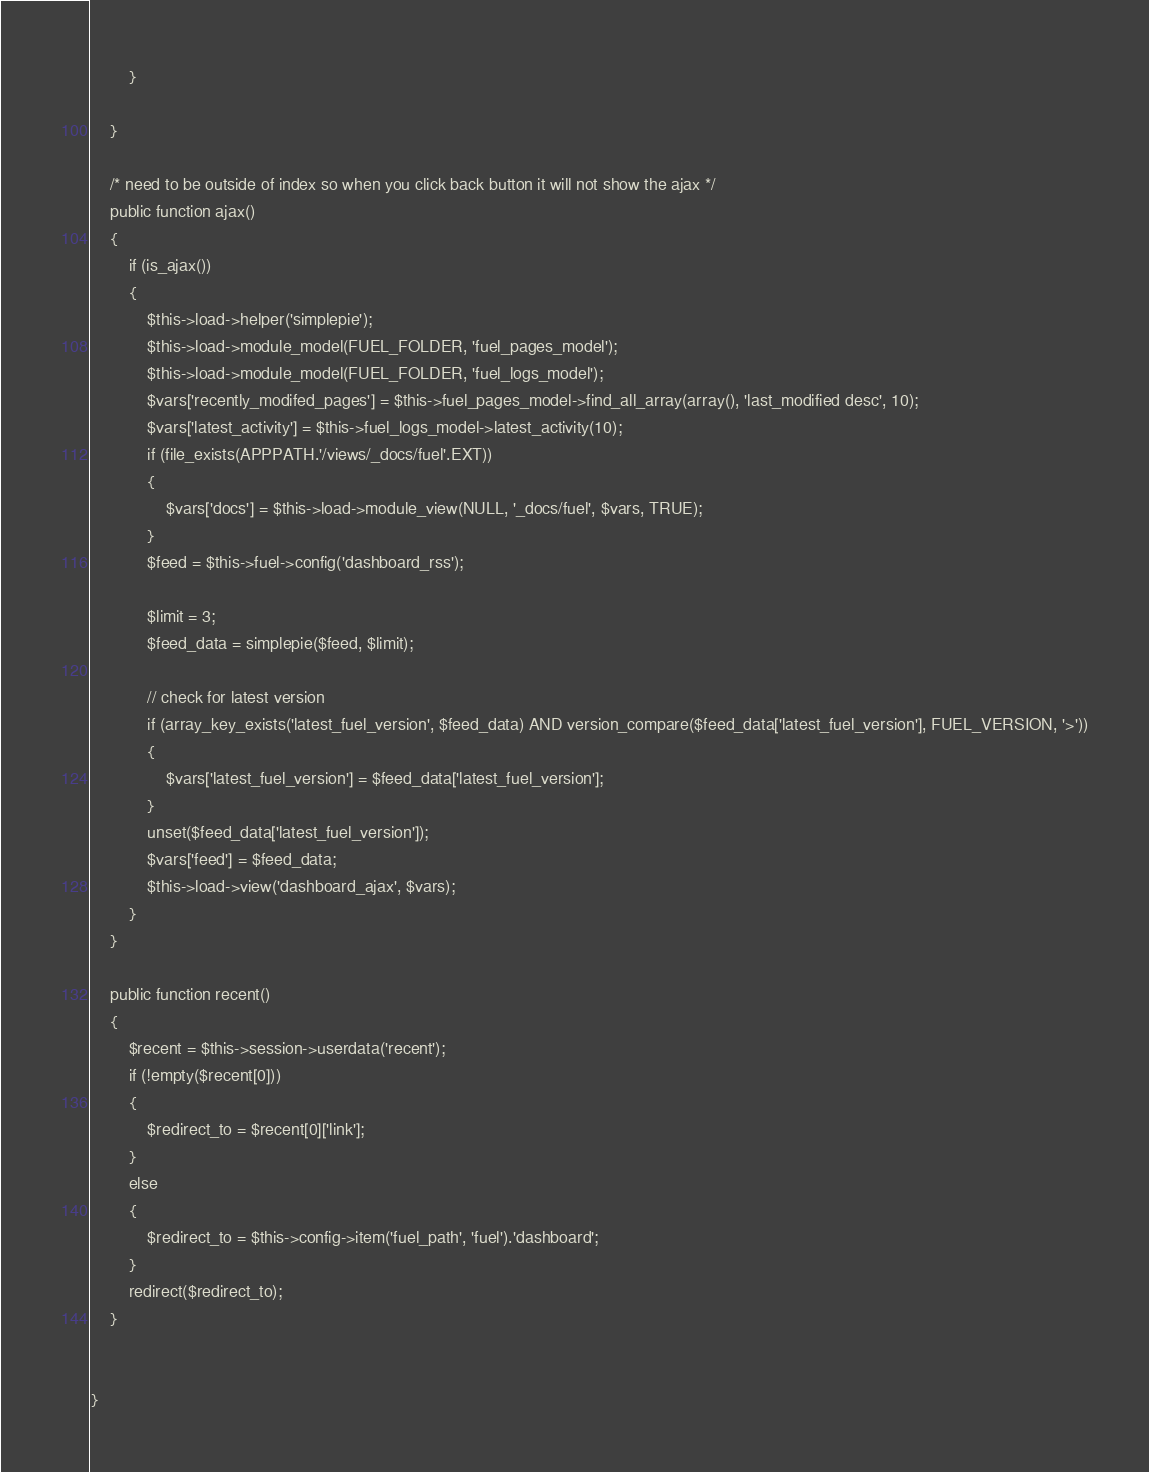<code> <loc_0><loc_0><loc_500><loc_500><_PHP_>		}

	}

	/* need to be outside of index so when you click back button it will not show the ajax */
	public function ajax()
	{
		if (is_ajax())
		{
			$this->load->helper('simplepie');
			$this->load->module_model(FUEL_FOLDER, 'fuel_pages_model');
			$this->load->module_model(FUEL_FOLDER, 'fuel_logs_model');
			$vars['recently_modifed_pages'] = $this->fuel_pages_model->find_all_array(array(), 'last_modified desc', 10);
			$vars['latest_activity'] = $this->fuel_logs_model->latest_activity(10);
			if (file_exists(APPPATH.'/views/_docs/fuel'.EXT))
			{
				$vars['docs'] = $this->load->module_view(NULL, '_docs/fuel', $vars, TRUE);
			}
			$feed = $this->fuel->config('dashboard_rss');

			$limit = 3;
			$feed_data = simplepie($feed, $limit);

			// check for latest version
			if (array_key_exists('latest_fuel_version', $feed_data) AND version_compare($feed_data['latest_fuel_version'], FUEL_VERSION, '>'))
			{
				$vars['latest_fuel_version'] = $feed_data['latest_fuel_version'];
			}
			unset($feed_data['latest_fuel_version']);
			$vars['feed'] = $feed_data;
			$this->load->view('dashboard_ajax', $vars);
		}
	}

	public function recent()
	{
		$recent = $this->session->userdata('recent');
		if (!empty($recent[0]))
		{
			$redirect_to = $recent[0]['link'];
		}
		else
		{
			$redirect_to = $this->config->item('fuel_path', 'fuel').'dashboard';
		}
		redirect($redirect_to);
	}


}</code> 